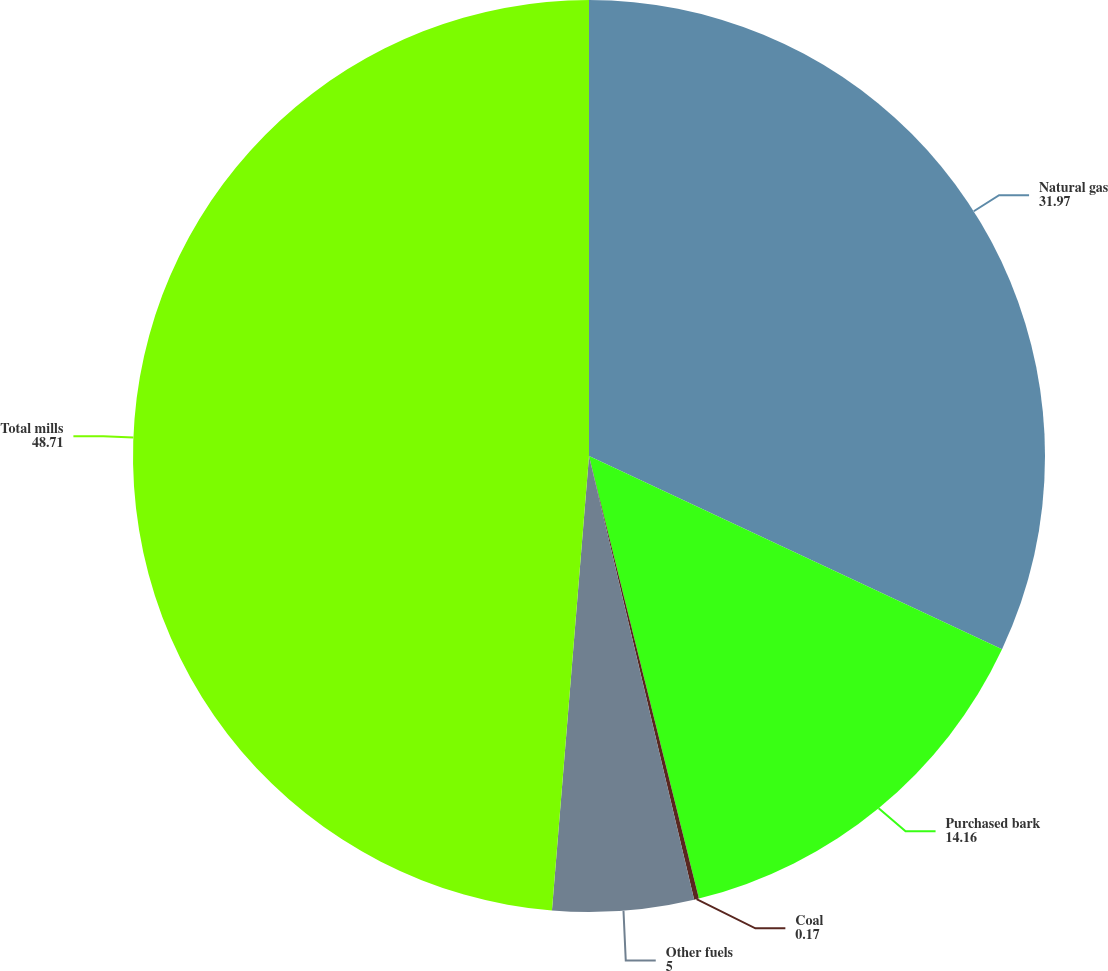<chart> <loc_0><loc_0><loc_500><loc_500><pie_chart><fcel>Natural gas<fcel>Purchased bark<fcel>Coal<fcel>Other fuels<fcel>Total mills<nl><fcel>31.97%<fcel>14.16%<fcel>0.17%<fcel>5.0%<fcel>48.71%<nl></chart> 